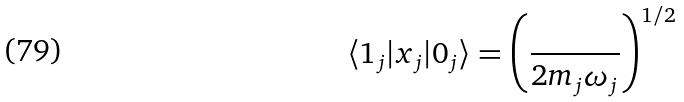<formula> <loc_0><loc_0><loc_500><loc_500>\langle 1 _ { j } | x _ { j } | 0 _ { j } \rangle = \left ( \frac { } { 2 m _ { j } \omega _ { j } } \right ) ^ { 1 / 2 }</formula> 